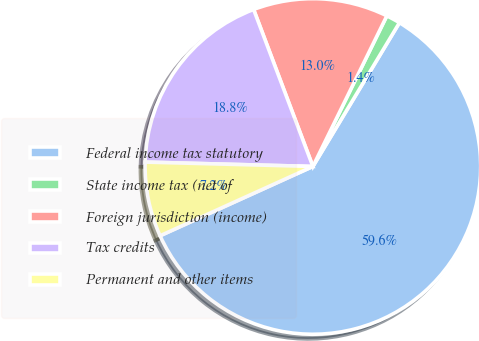<chart> <loc_0><loc_0><loc_500><loc_500><pie_chart><fcel>Federal income tax statutory<fcel>State income tax (net of<fcel>Foreign jurisdiction (income)<fcel>Tax credits<fcel>Permanent and other items<nl><fcel>59.6%<fcel>1.36%<fcel>13.01%<fcel>18.84%<fcel>7.19%<nl></chart> 